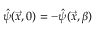<formula> <loc_0><loc_0><loc_500><loc_500>\hat { \psi } ( \vec { x } , 0 ) = - \hat { \psi } ( \vec { x } , \beta )</formula> 